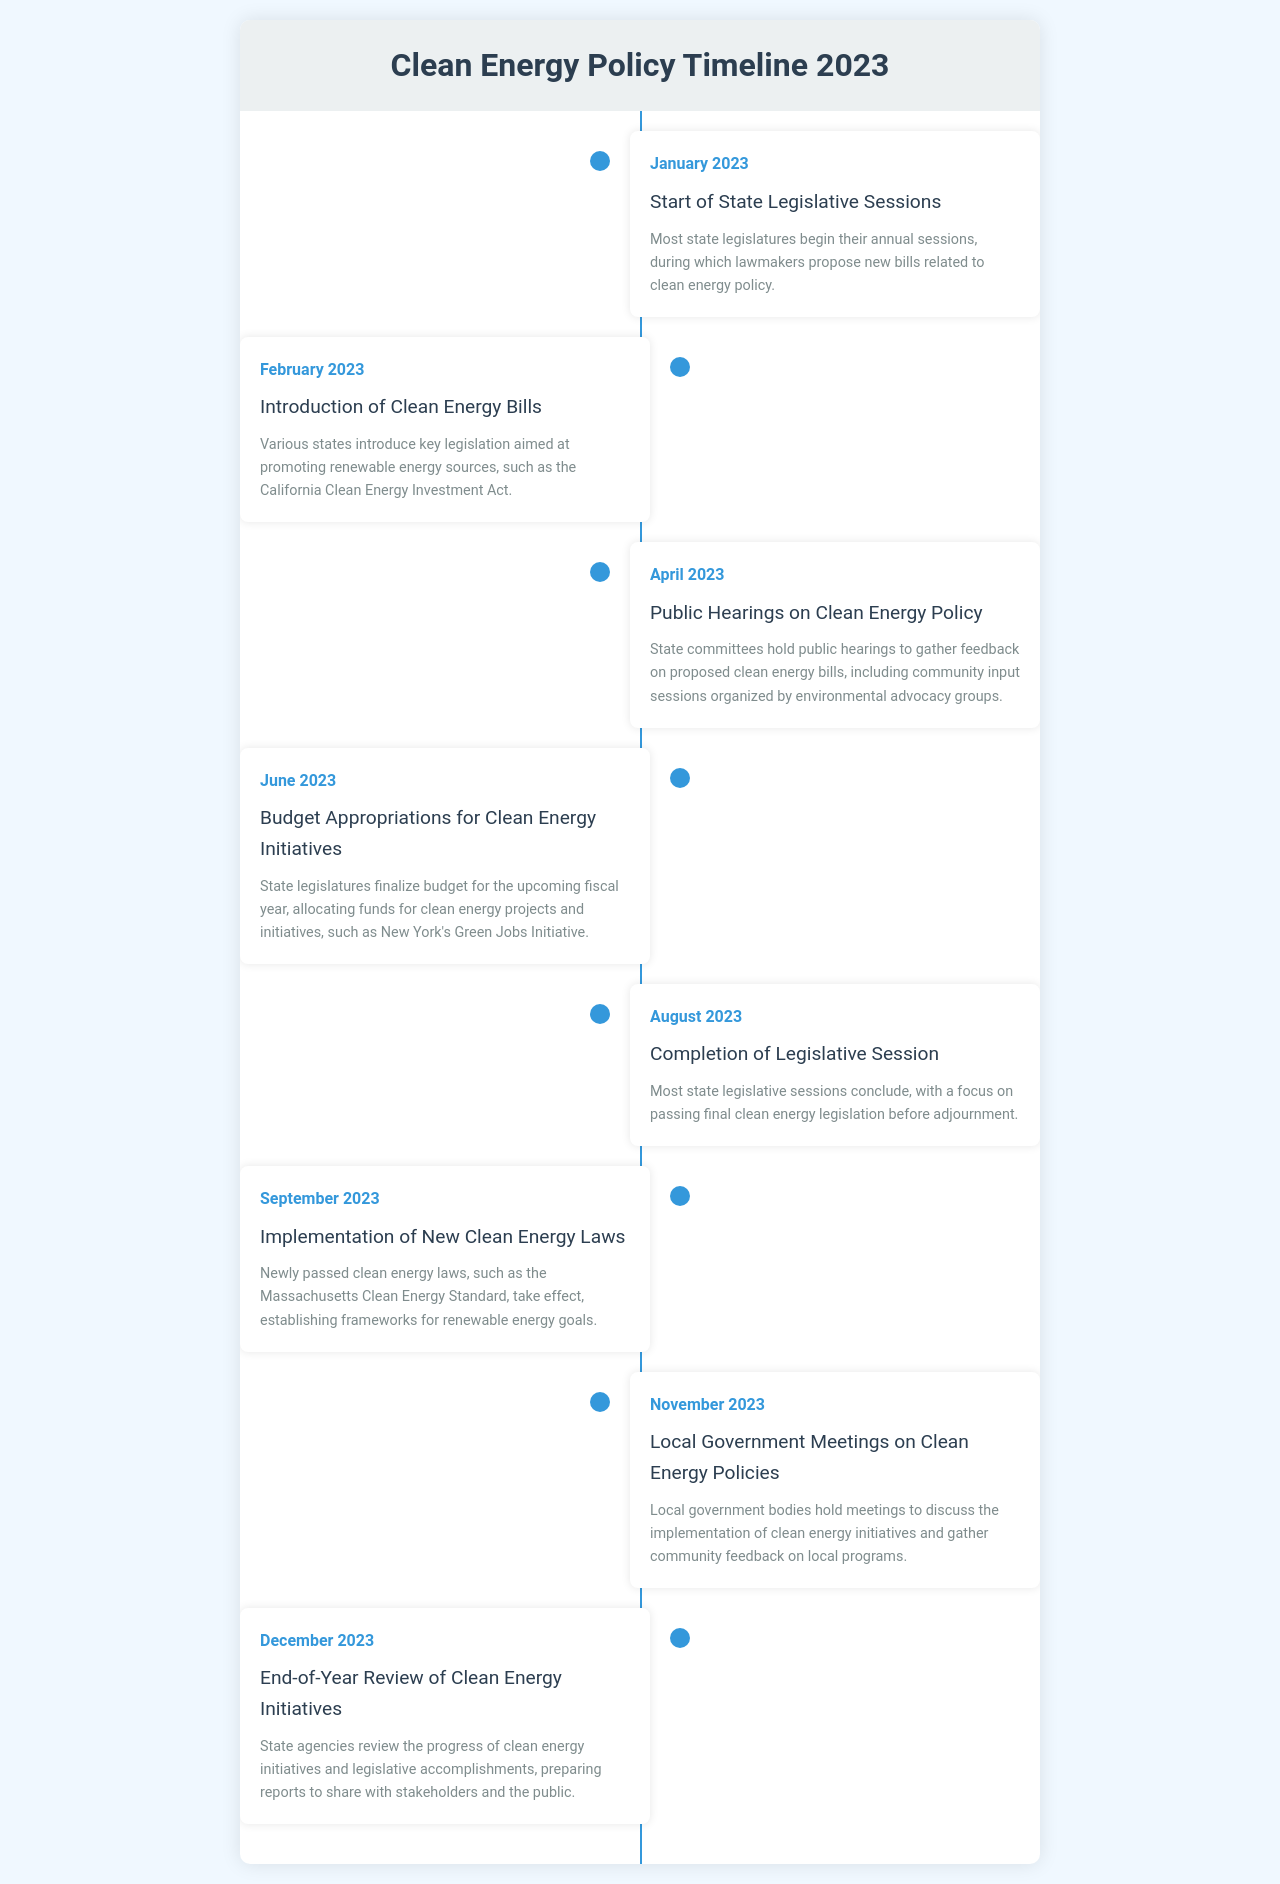What month do most state legislatures begin their sessions? The document states that most state legislatures begin their annual sessions in January 2023.
Answer: January 2023 What legislation was introduced in February 2023? According to the document, one of the key legislations introduced is the California Clean Energy Investment Act.
Answer: California Clean Energy Investment Act When are public hearings on clean energy policy held? The document mentions that public hearings on clean energy policy take place in April 2023.
Answer: April 2023 What is allocated in June 2023 for clean energy projects? The document indicates that budget appropriations for clean energy initiatives are finalized.
Answer: Budget What happens in August 2023 regarding legislative sessions? The document states that most state legislative sessions conclude in August 2023.
Answer: Conclude What new clean energy laws take effect in September 2023? The document specifies that the Massachusetts Clean Energy Standard takes effect.
Answer: Massachusetts Clean Energy Standard What type of meetings occur in November 2023? The document discusses that local government meetings on clean energy policies are held.
Answer: Local government meetings What is reviewed in December 2023? According to the document, an end-of-year review of clean energy initiatives is conducted.
Answer: End-of-year review Which group organizes community input sessions in April 2023? The document states that environmental advocacy groups organize community input sessions during public hearings.
Answer: Environmental advocacy groups What is the focus of state committees in April 2023? The document says that state committees hold public hearings to gather feedback on proposed clean energy bills.
Answer: Gather feedback 